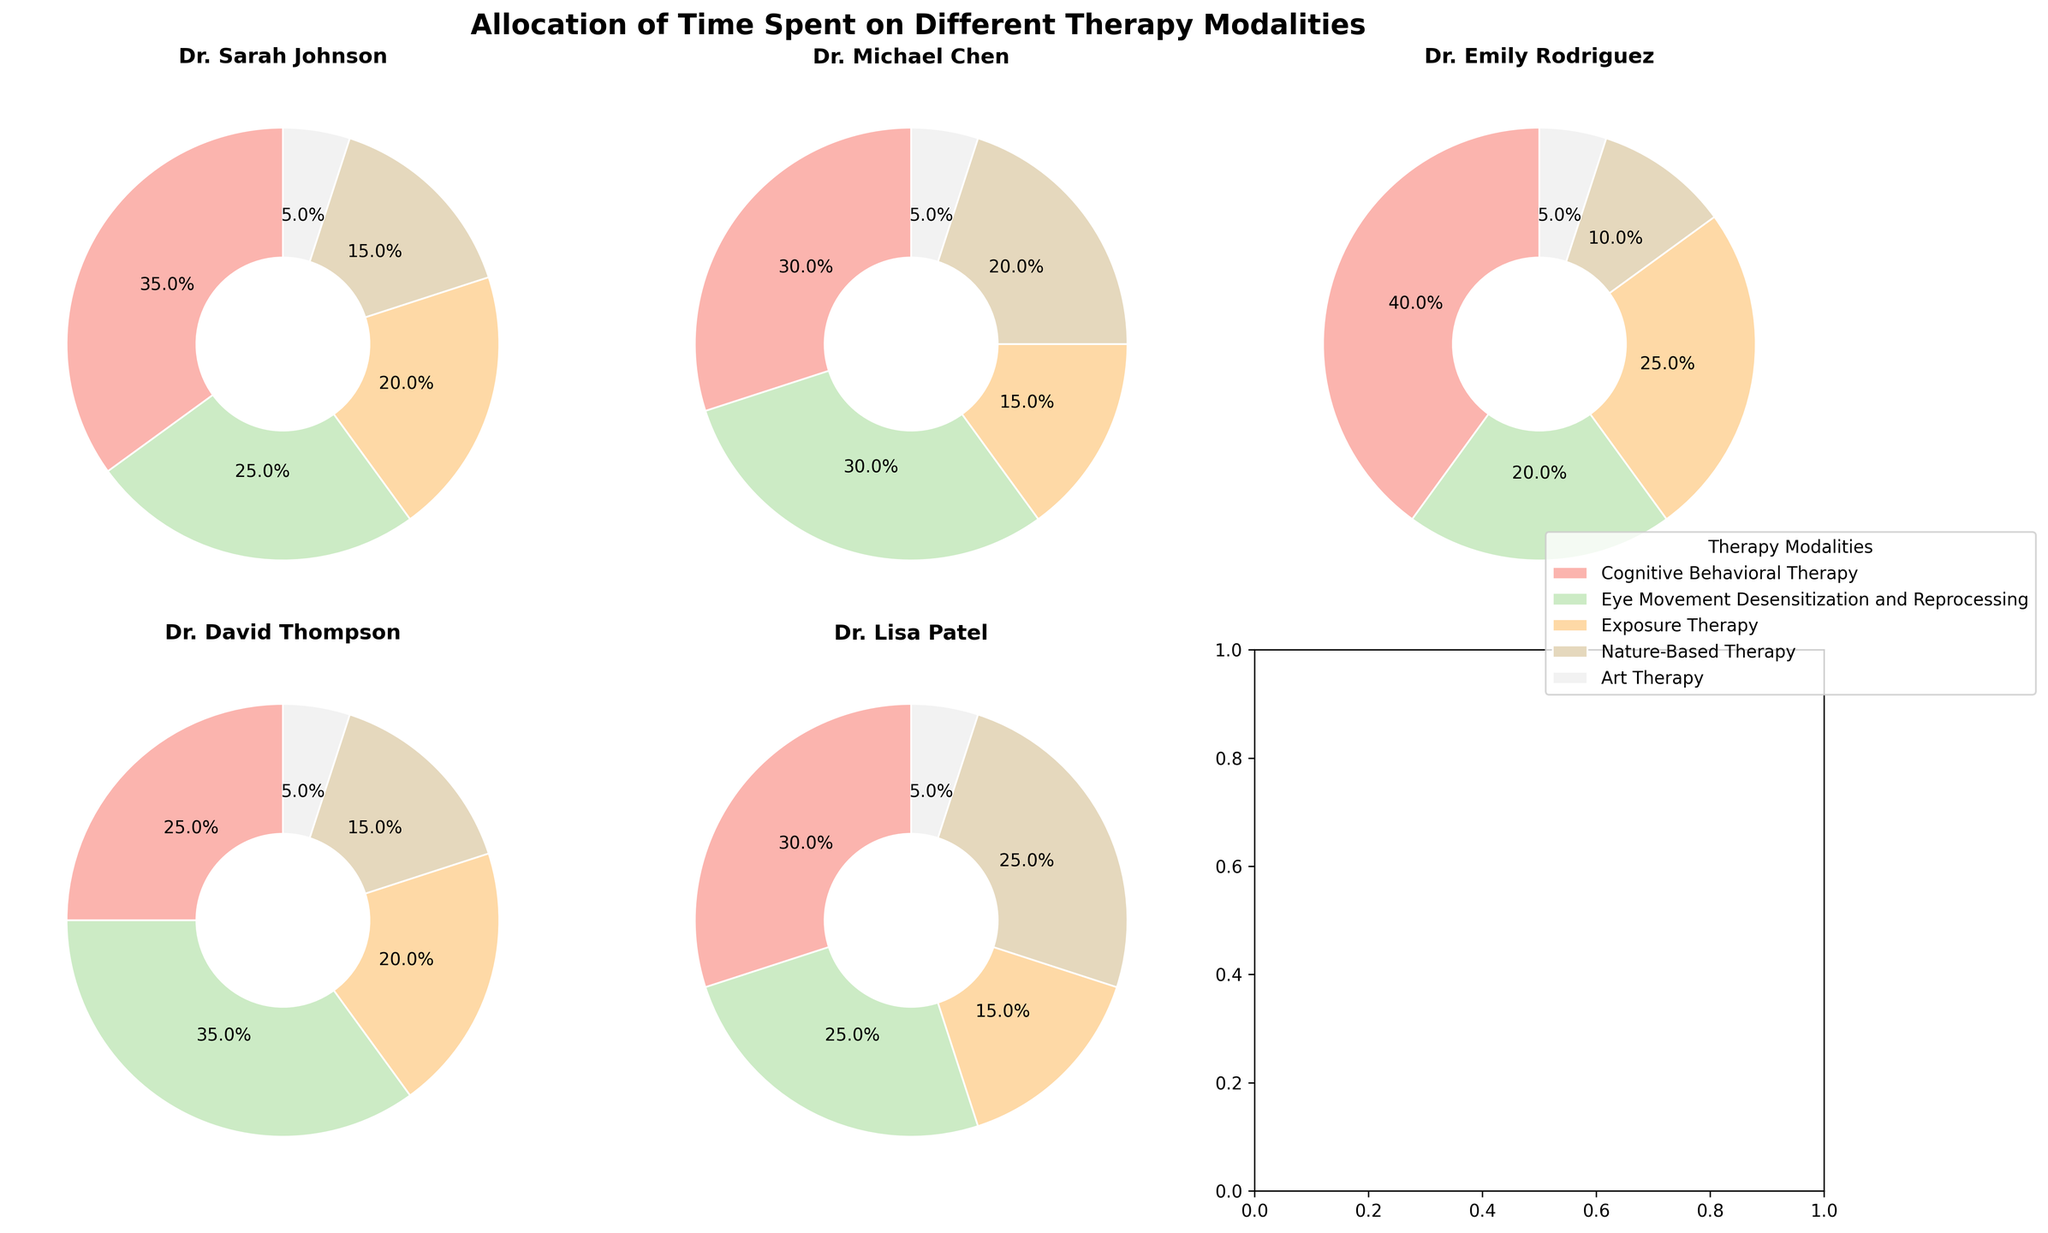What is the title of the figure? The title of the figure is prominently displayed at the top and provides a general description of the plot. In this case, it summarizes the focus of the data visualization.
Answer: Allocation of Time Spent on Different Therapy Modalities Which therapist spends the most time on Cognitive Behavioral Therapy? By examining the pie charts for each therapist, you can identify the one who allocates the largest percentage to Cognitive Behavioral Therapy. Dr. Emily Rodriguez allocates 40% to this modality, which is the highest among all therapists.
Answer: Dr. Emily Rodriguez What is the average percentage of time spent on Eye Movement Desensitization and Reprocessing across the therapists? To find the average, add the percentages for Eye Movement Desensitization and Reprocessing for all therapists (25 + 30 + 20 + 35 + 25) and divide by the number of therapists (5). The sum is 135, so the average is 135/5 = 27%.
Answer: 27% Which therapists allocate more than 20% of their time to Exposure Therapy? Look at the pie chart segments for Exposure Therapy for each therapist. Dr. Sarah Johnson (20%), Dr. Michael Chen (15%), Dr. Emily Rodriguez (25%), Dr. David Thompson (20%), and Dr. Lisa Patel (15%) show that only Dr. Emily Rodriguez allocates more than 20%.
Answer: Dr. Emily Rodriguez Which therapy modality has the smallest allocation of time across all therapists? By visually comparing the pie charts, it's evident that Art Therapy consistently has the smallest segment across all therapists, suggesting it has the least allocation time.
Answer: Art Therapy Which therapist has the most evenly distributed time allocation among all modalities? To determine the most evenly distributed time allocation, observe the pie charts where the segments are closest in size. Dr. Michael Chen allocates time as 30%, 30%, 15%, 20%, 5%, which is relatively balanced compared to others.
Answer: Dr. Michael Chen What is the difference in percentage of time spent on Nature-Based Therapy between Dr. Michael Chen and Dr. Emily Rodriguez? Compare the allocation of time for Nature-Based Therapy between Dr. Michael Chen (20%) and Dr. Emily Rodriguez (10%) and calculate the difference: 20 - 10 = 10%.
Answer: 10% Which therapist allocates the least time to Cognitive Behavioral Therapy, and what is that percentage? By visually scanning through the pie charts, Dr. David Thompson has the least allocation for Cognitive Behavioral Therapy at 25%.
Answer: Dr. David Thompson, 25% In total, how much percentage time is spent by all therapists combined on Art Therapy? Adding the time spent on Art Therapy by each therapist: 5% (Dr. Sarah Johnson), 5% (Dr. Michael Chen), 5% (Dr. Emily Rodriguez), 5% (Dr. David Thompson), 5% (Dr. Lisa Patel), the total is 5+5+5+5+5 = 25%.
Answer: 25% 